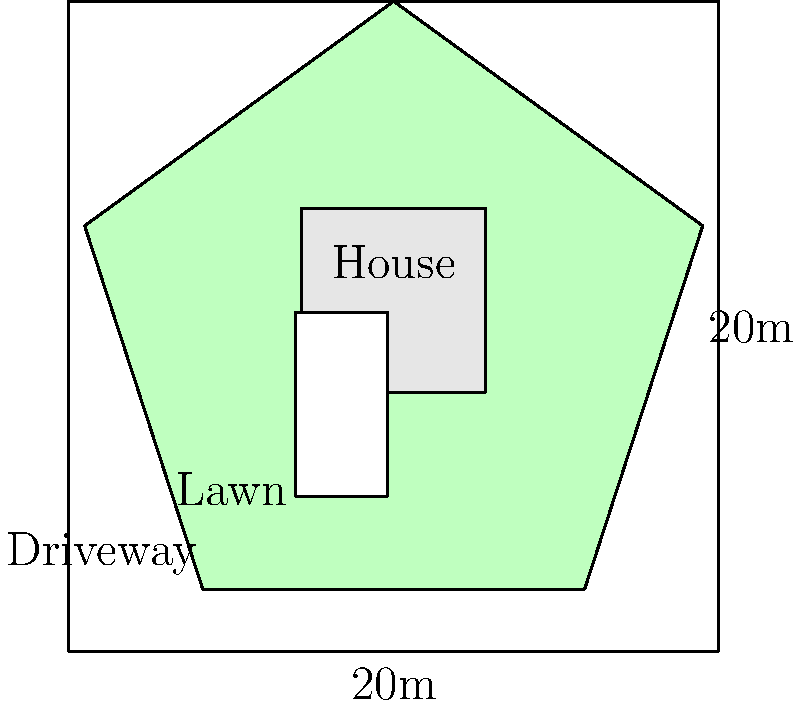As a first-time homebuyer, you're considering the landscaping costs for your new property. Given the yard layout sketch above, where the lot is a 20m x 20m square, estimate the cost of sodding the lawn area if sod costs $5 per square meter. Round your answer to the nearest hundred dollars. To estimate the cost of sodding the lawn, we need to follow these steps:

1. Calculate the total area of the lot:
   $\text{Total Area} = 20\text{m} \times 20\text{m} = 400\text{m}^2$

2. Estimate the areas of the house and driveway:
   - House: Approximately $\frac{1}{4}$ of the lot area = $100\text{m}^2$
   - Driveway: Approximately $\frac{1}{16}$ of the lot area = $25\text{m}^2$

3. Calculate the lawn area:
   $\text{Lawn Area} = \text{Total Area} - (\text{House Area} + \text{Driveway Area})$
   $\text{Lawn Area} = 400\text{m}^2 - (100\text{m}^2 + 25\text{m}^2) = 275\text{m}^2$

4. Calculate the cost of sodding:
   $\text{Cost} = \text{Lawn Area} \times \text{Cost per square meter}$
   $\text{Cost} = 275\text{m}^2 \times \$5/\text{m}^2 = \$1,375$

5. Round to the nearest hundred dollars:
   $\$1,375$ rounds to $\$1,400$
Answer: $1,400 